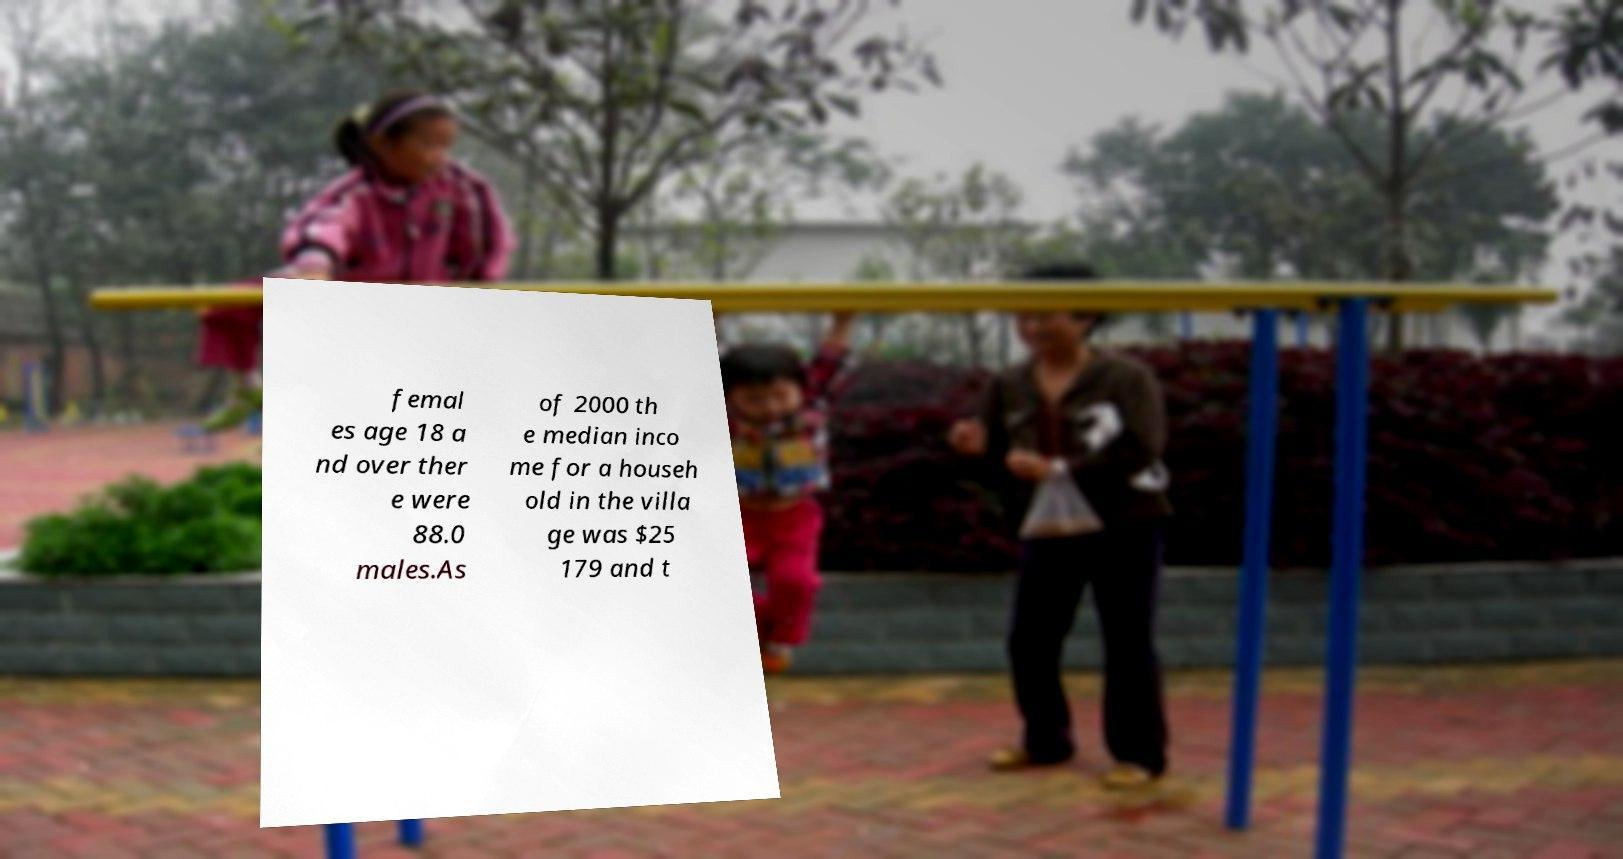Please read and relay the text visible in this image. What does it say? femal es age 18 a nd over ther e were 88.0 males.As of 2000 th e median inco me for a househ old in the villa ge was $25 179 and t 